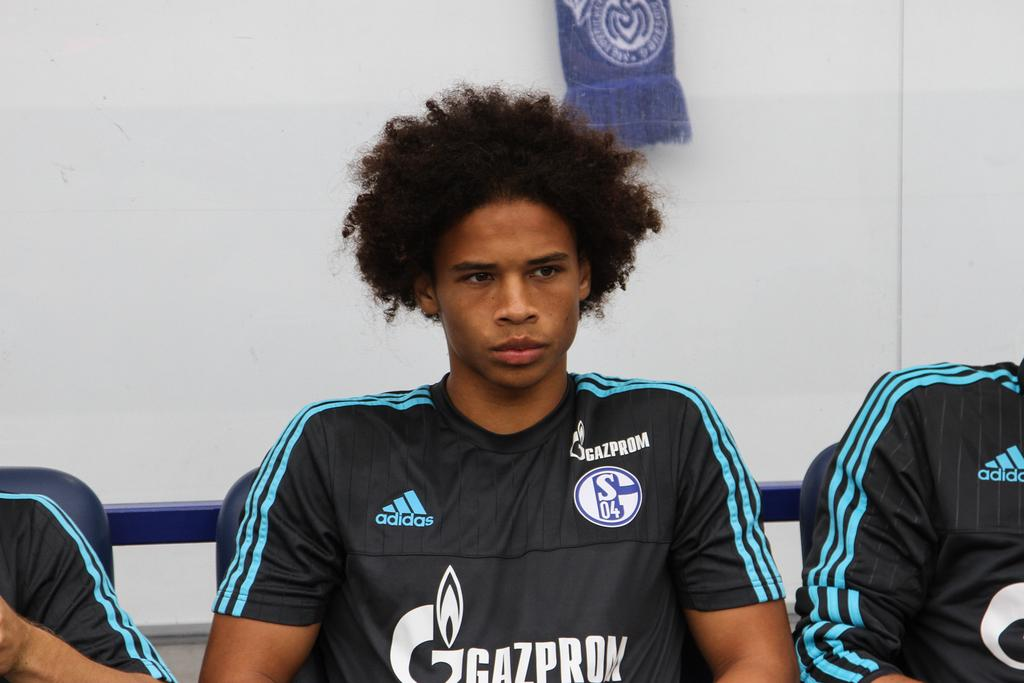<image>
Share a concise interpretation of the image provided. a player on Gazprom team is sitting down 